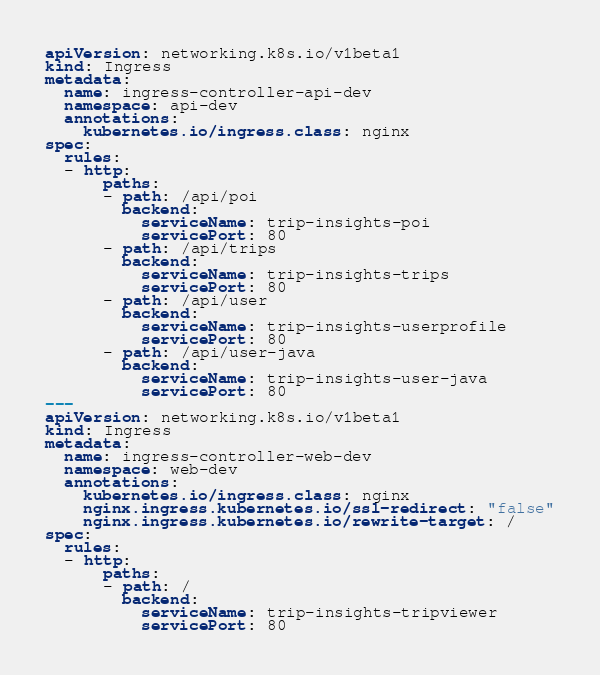Convert code to text. <code><loc_0><loc_0><loc_500><loc_500><_YAML_>apiVersion: networking.k8s.io/v1beta1
kind: Ingress
metadata:
  name: ingress-controller-api-dev
  namespace: api-dev
  annotations:
    kubernetes.io/ingress.class: nginx
spec:
  rules:
  - http:
      paths:
      - path: /api/poi
        backend:
          serviceName: trip-insights-poi
          servicePort: 80
      - path: /api/trips
        backend:
          serviceName: trip-insights-trips
          servicePort: 80
      - path: /api/user
        backend:
          serviceName: trip-insights-userprofile
          servicePort: 80
      - path: /api/user-java
        backend:
          serviceName: trip-insights-user-java
          servicePort: 80
---
apiVersion: networking.k8s.io/v1beta1
kind: Ingress
metadata:
  name: ingress-controller-web-dev
  namespace: web-dev
  annotations:
    kubernetes.io/ingress.class: nginx
    nginx.ingress.kubernetes.io/ssl-redirect: "false"
    nginx.ingress.kubernetes.io/rewrite-target: /
spec:
  rules:
  - http:
      paths:
      - path: /
        backend:
          serviceName: trip-insights-tripviewer
          servicePort: 80</code> 